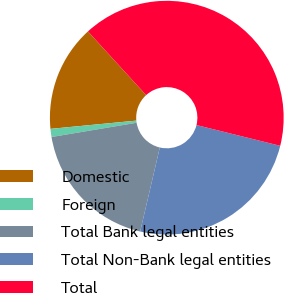Convert chart to OTSL. <chart><loc_0><loc_0><loc_500><loc_500><pie_chart><fcel>Domestic<fcel>Foreign<fcel>Total Bank legal entities<fcel>Total Non-Bank legal entities<fcel>Total<nl><fcel>14.74%<fcel>1.12%<fcel>18.7%<fcel>24.79%<fcel>40.65%<nl></chart> 